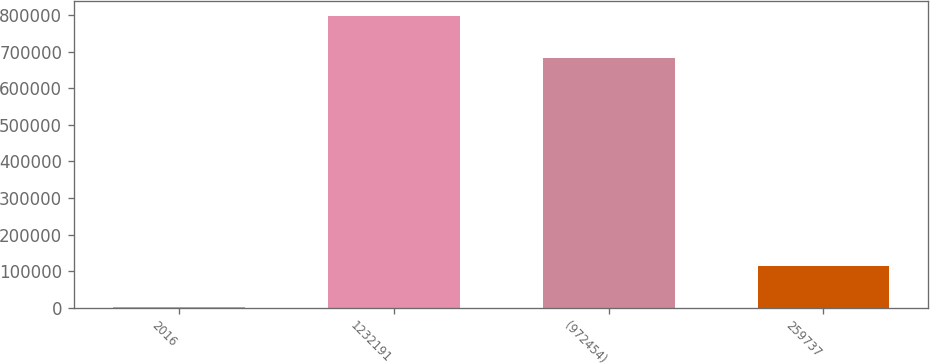Convert chart. <chart><loc_0><loc_0><loc_500><loc_500><bar_chart><fcel>2016<fcel>1232191<fcel>(972454)<fcel>259737<nl><fcel>2014<fcel>797441<fcel>682430<fcel>115011<nl></chart> 